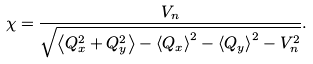<formula> <loc_0><loc_0><loc_500><loc_500>\chi = \frac { V _ { n } } { \sqrt { \left \langle Q _ { x } ^ { 2 } + Q _ { y } ^ { 2 } \right \rangle - \left \langle Q _ { x } \right \rangle ^ { 2 } - \left \langle Q _ { y } \right \rangle ^ { 2 } - V _ { n } ^ { 2 } } } .</formula> 